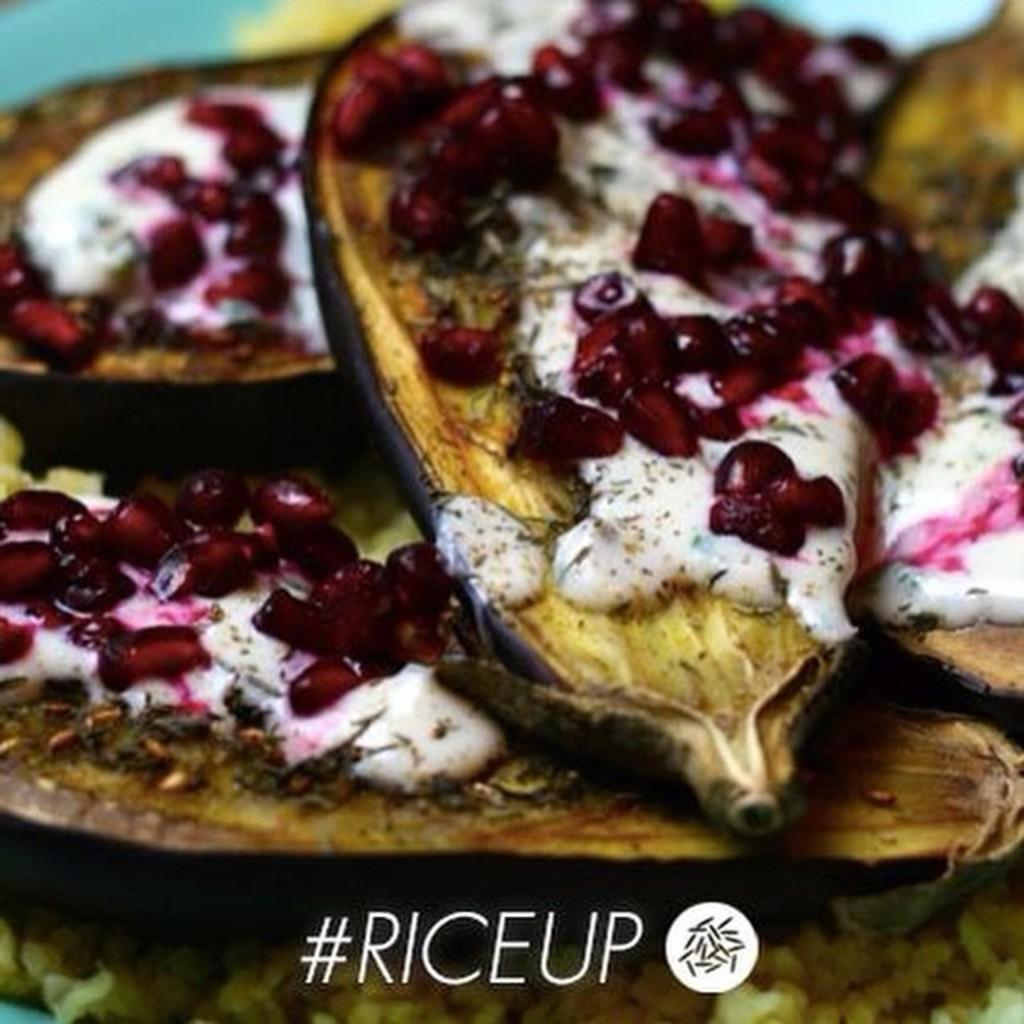What type of food items can be seen in the image? There are food items in the image, including pomegranate seeds. Can you describe the specific food item that is mentioned in the second fact? Yes, there are pomegranate seeds in the image. Is there any additional information about the image that is not related to the food items? Yes, there is a watermark on the image. Where is the toothbrush located in the image? There is no toothbrush present in the image. What type of seat can be seen in the image? There is no seat present in the image. 